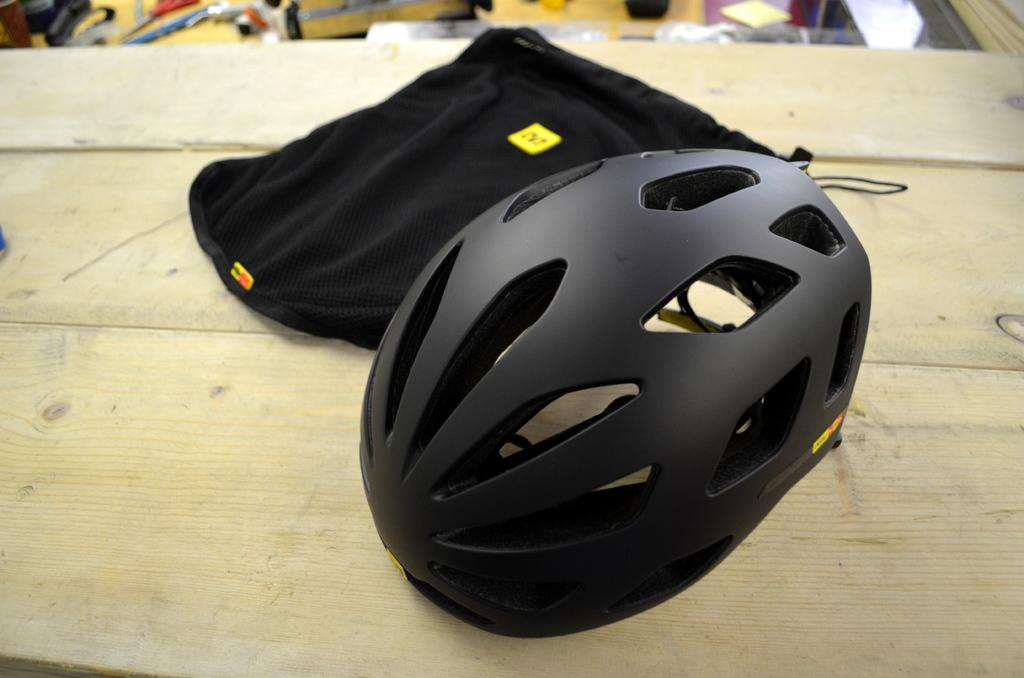What color are the objects in the center of the image? The objects in the center of the image are black in color. What colors are the objects in the background of the image? The objects in the background of the image are yellow and white in color. Can you describe the distribution of colors in the image? The image features black objects in the center and yellow and white objects in the background. Can you see any fish jumping out of the water in the image? There is no water or fish present in the image. 